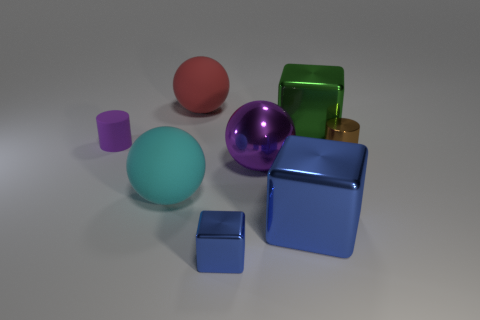The metallic ball has what color?
Ensure brevity in your answer.  Purple. What is the color of the small thing that is to the left of the small cube?
Give a very brief answer. Purple. There is a rubber object behind the purple matte cylinder; how many cyan matte things are on the right side of it?
Keep it short and to the point. 0. There is a red sphere; does it have the same size as the cylinder behind the shiny cylinder?
Your answer should be compact. No. Is there a metal object of the same size as the cyan sphere?
Offer a very short reply. Yes. What number of things are either large purple matte objects or small blue objects?
Provide a succinct answer. 1. Does the purple object behind the big purple metal sphere have the same size as the block that is on the left side of the large metal sphere?
Keep it short and to the point. Yes. Are there any gray shiny objects that have the same shape as the large red rubber object?
Ensure brevity in your answer.  No. Is the number of tiny blocks right of the small blue metal block less than the number of tiny metallic cylinders?
Your answer should be compact. Yes. Is the shape of the tiny brown thing the same as the small purple rubber object?
Offer a terse response. Yes. 